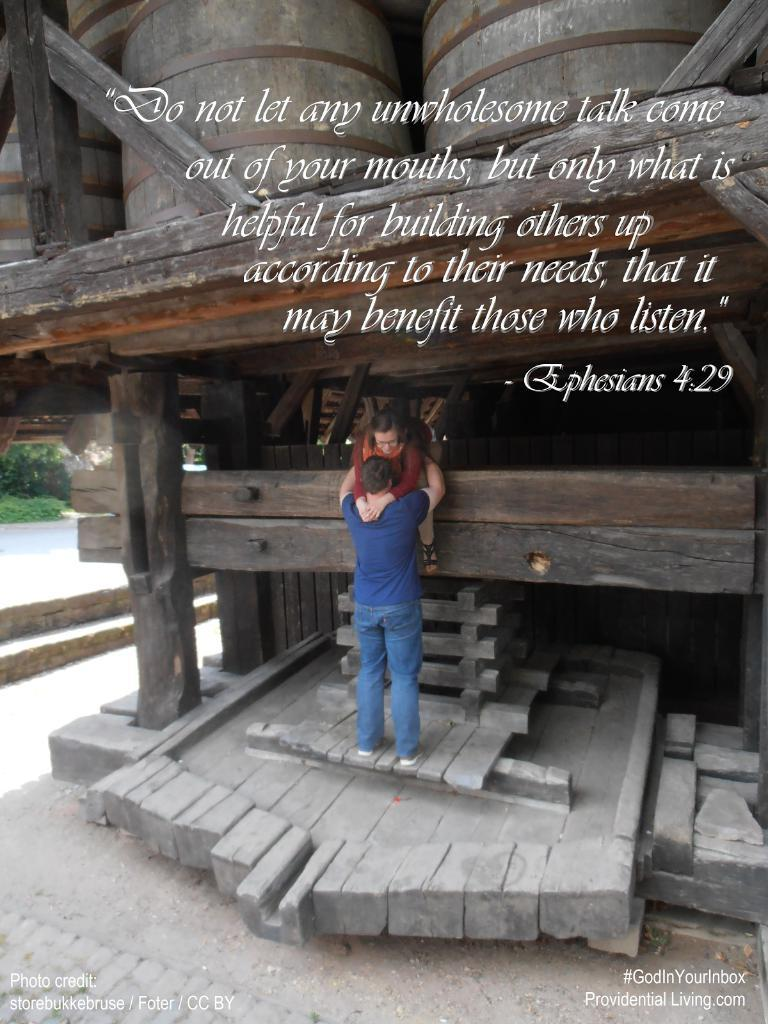How many people are in the image? There are two persons in the image. What colors are the dresses worn by the persons? One person is wearing a brown dress, and the other person is wearing a blue dress. What else can be seen in the image besides the two persons? There is text or writing visible in the image. What type of soup is being served on the sofa in the image? There is no sofa or soup present in the image. What time of day is depicted in the image, based on the hour? The provided facts do not mention any specific time or hour, so it cannot be determined from the image. 